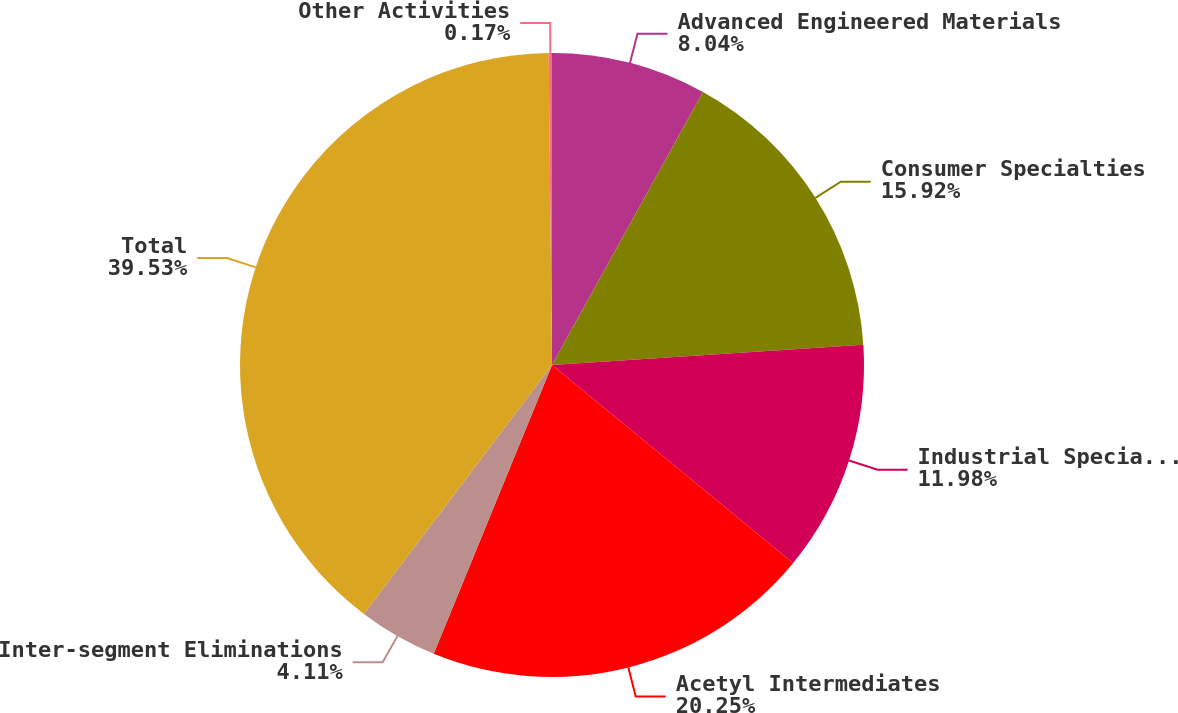Convert chart. <chart><loc_0><loc_0><loc_500><loc_500><pie_chart><fcel>Advanced Engineered Materials<fcel>Consumer Specialties<fcel>Industrial Specialties<fcel>Acetyl Intermediates<fcel>Inter-segment Eliminations<fcel>Total<fcel>Other Activities<nl><fcel>8.04%<fcel>15.92%<fcel>11.98%<fcel>20.25%<fcel>4.11%<fcel>39.53%<fcel>0.17%<nl></chart> 